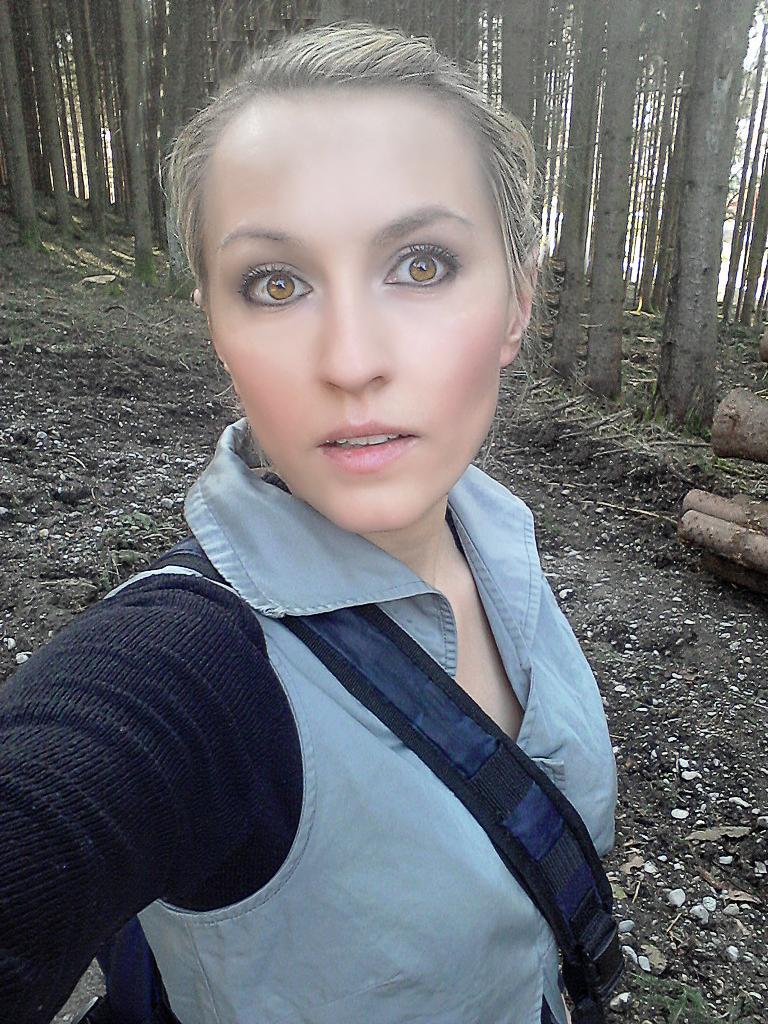Could you give a brief overview of what you see in this image? In this picture we can see a woman. In the background there are trees. 